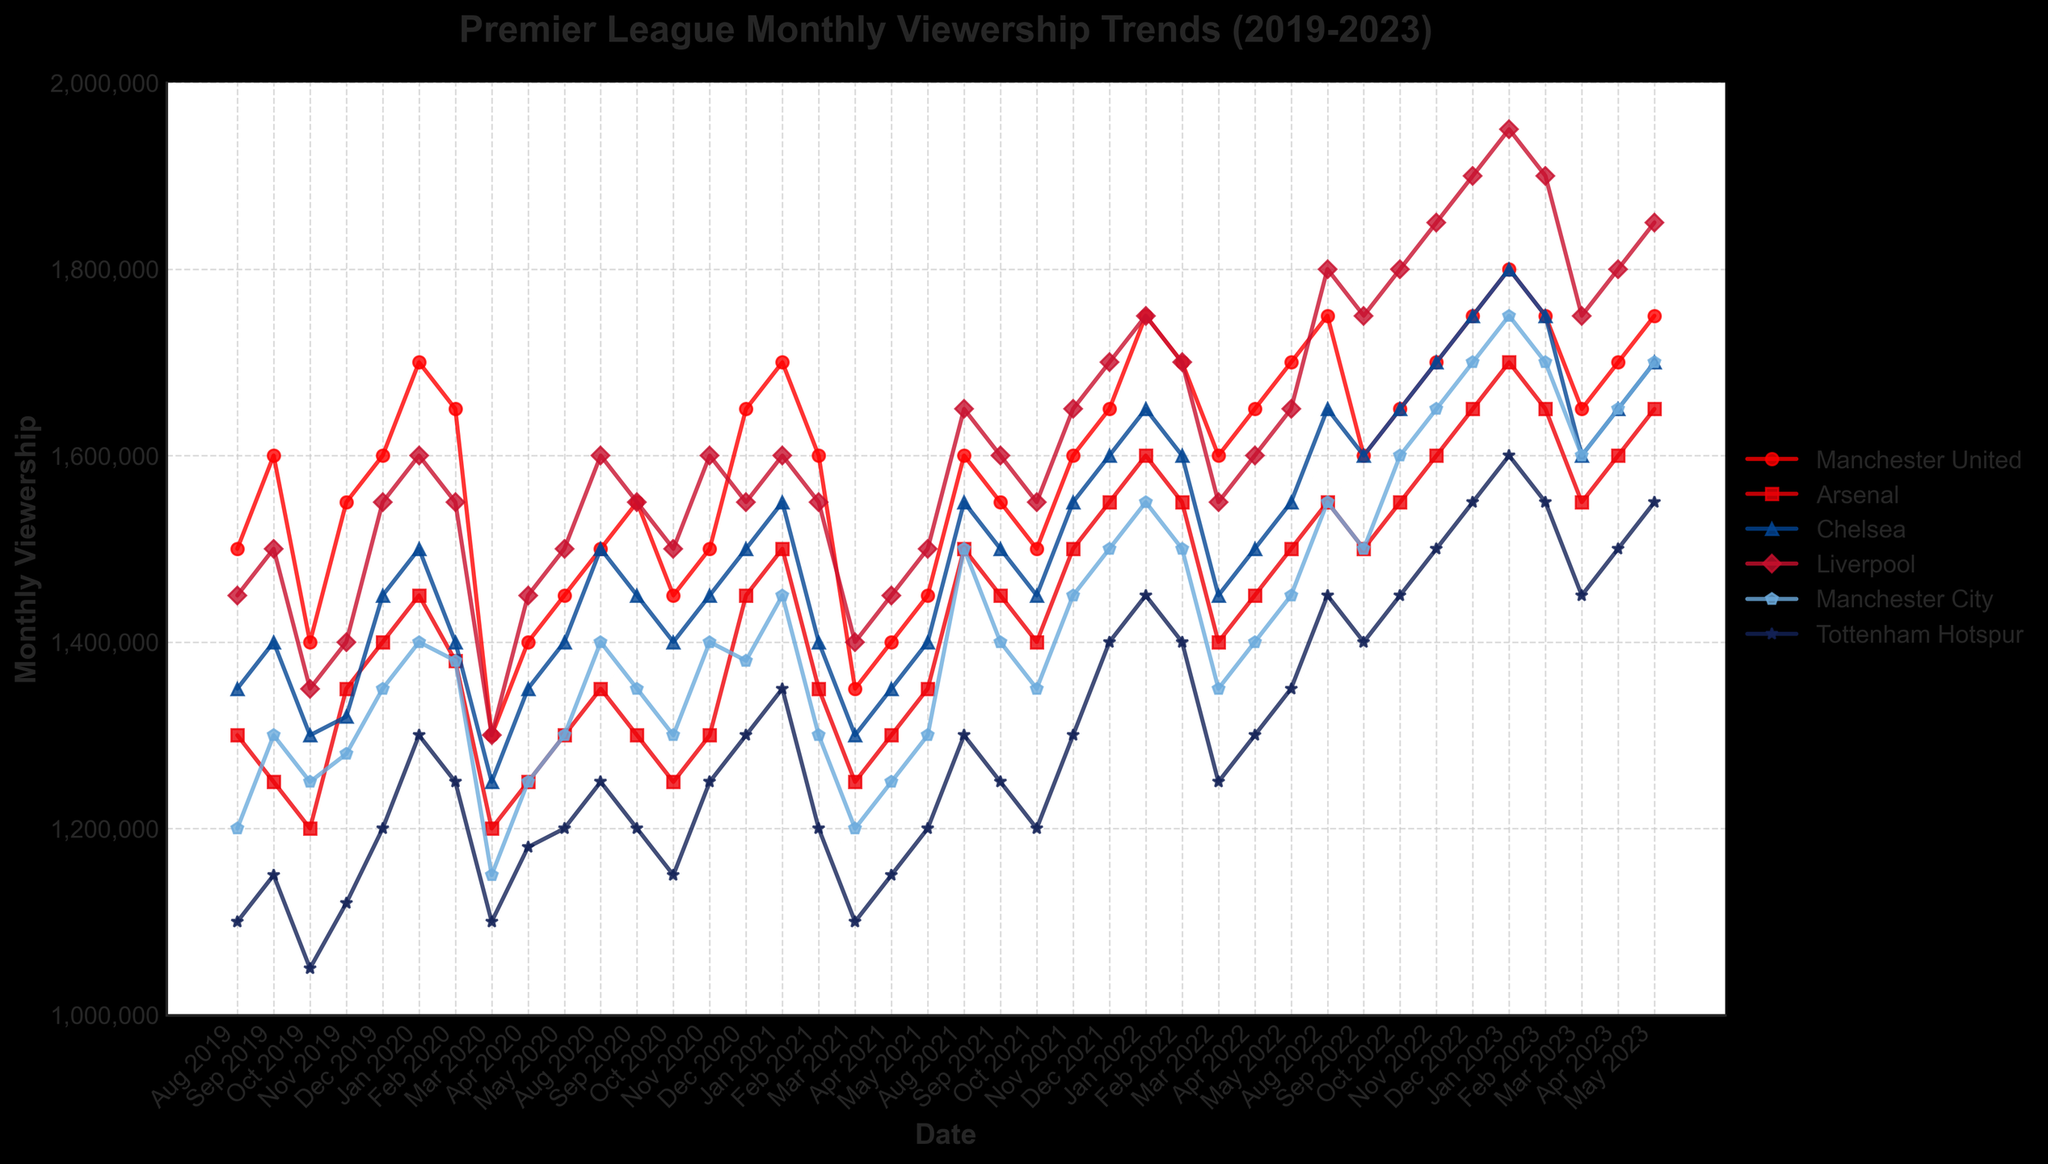What is the title of the plot? The title of the plot is shown at the top center in bold and larger font. It reads "Premier League Monthly Viewership Trends (2019-2023)."
Answer: Premier League Monthly Viewership Trends (2019-2023) Which team has the highest viewership in January 2023? To determine this, look at the data points for January 2023 across all the teams represented on the x-axis and identify the highest point on the y-axis. Liverpool has the highest viewership in January 2023 at 1,950,000.
Answer: Liverpool How do the viewership numbers for Chelsea in August 2022 compare to those in August 2019? Refer to the plot at data points for Chelsea in August 2022 and August 2019. Chelsea had 1,650,000 viewership in August 2022 and 1,350,000 in August 2019. The difference is 1,650,000 - 1,350,000 = 300,000.
Answer: 300,000 What is the overall trend for Arsenal's viewership from August 2019 to May 2023? Follow the line representing Arsenal from the start to the end of the time period. Arsenal’s viewership shows a generally increasing trend over this period, starting around 1,300,000 in August 2019 and reaching approximately 1,650,000 in May 2023.
Answer: Increasing Which month and year had the lowest viewership for Tottenham Hotspur? Identify the lowest data point in the Tottenham Hotspur series. In October 2019, Tottenham Hotspur had its lowest viewership at 1,050,000.
Answer: October 2019 What is the average viewership for Manchester United in the year 2022? Identify the data points for Manchester United for each month in 2022 (Aug, Sep, Oct, Nov, Dec). The values are 1,750,000, 1,600,000, 1,650,000, 1,700,000, 1,750,000. The sum is 8,450,000 and the average is 8,450,000 / 5 = 1,690,000.
Answer: 1,690,000 Compare the viewership trends of Liverpool and Manchester City in 2020. Which team had a more consistent viewership? Examine the trend lines for both teams throughout the year 2020. Liverpool’s viewership remains higher and more stable (1,550,000 – 1,600,000), while Manchester City shows more fluctuation. Hence, Liverpool had more consistent viewership.
Answer: Liverpool In what month and year did Manchester City's viewership first exceed 1,600,000? Track the Manchester City line to see when it first crosses the 1,600,000 mark. This happens in November 2022 where the viewership is 1,650,000.
Answer: November 2022 What is the highest recorded viewership for any team during the entire period, and which team achieved it? Look for the highest point along the y-axis across all series. Liverpool’s viewership in January 2023 is the highest at 1,950,000.
Answer: Liverpool in January 2023 